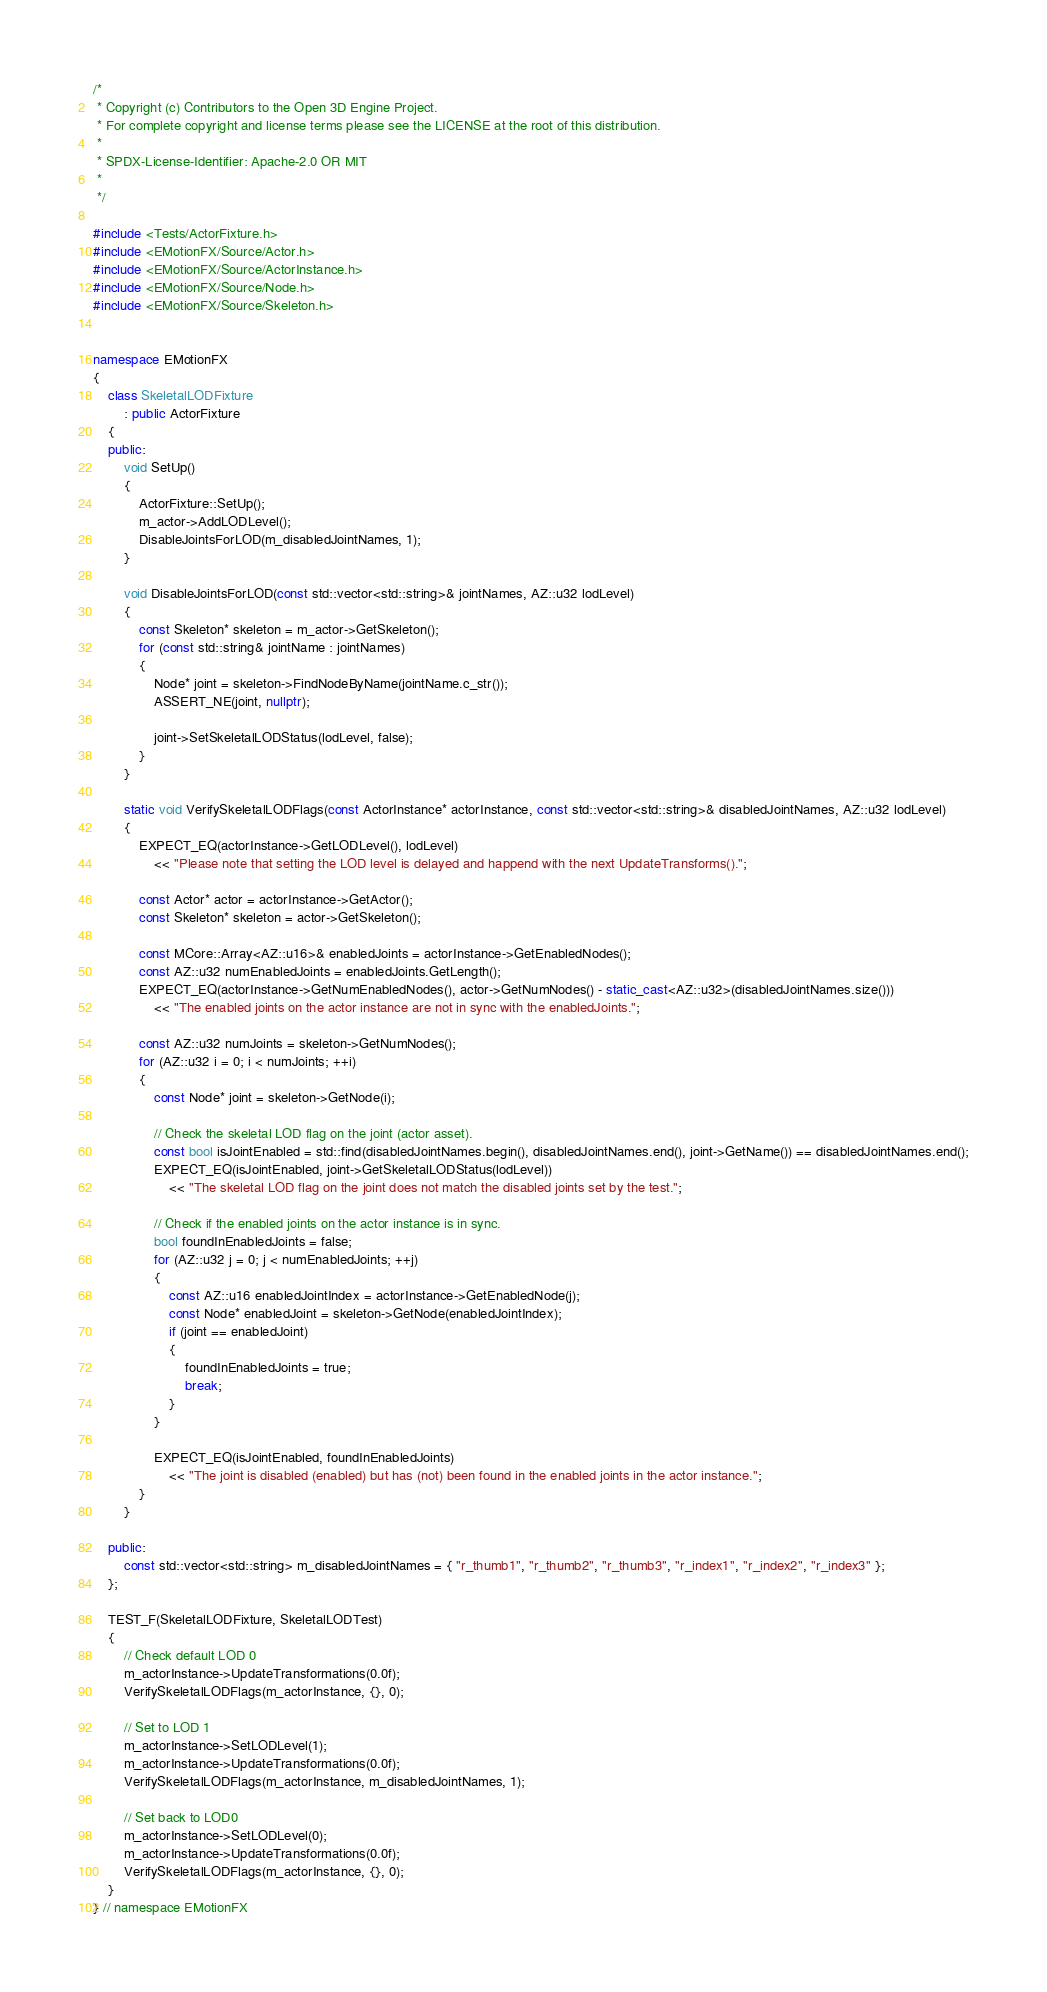Convert code to text. <code><loc_0><loc_0><loc_500><loc_500><_C++_>/*
 * Copyright (c) Contributors to the Open 3D Engine Project.
 * For complete copyright and license terms please see the LICENSE at the root of this distribution.
 *
 * SPDX-License-Identifier: Apache-2.0 OR MIT
 *
 */

#include <Tests/ActorFixture.h>
#include <EMotionFX/Source/Actor.h>
#include <EMotionFX/Source/ActorInstance.h>
#include <EMotionFX/Source/Node.h>
#include <EMotionFX/Source/Skeleton.h>


namespace EMotionFX
{
    class SkeletalLODFixture
        : public ActorFixture
    {
    public:
        void SetUp()
        {
            ActorFixture::SetUp();
            m_actor->AddLODLevel();
            DisableJointsForLOD(m_disabledJointNames, 1);
        }

        void DisableJointsForLOD(const std::vector<std::string>& jointNames, AZ::u32 lodLevel)
        {
            const Skeleton* skeleton = m_actor->GetSkeleton();
            for (const std::string& jointName : jointNames)
            {
                Node* joint = skeleton->FindNodeByName(jointName.c_str());
                ASSERT_NE(joint, nullptr);

                joint->SetSkeletalLODStatus(lodLevel, false);
            }
        }

        static void VerifySkeletalLODFlags(const ActorInstance* actorInstance, const std::vector<std::string>& disabledJointNames, AZ::u32 lodLevel)
        {
            EXPECT_EQ(actorInstance->GetLODLevel(), lodLevel)
                << "Please note that setting the LOD level is delayed and happend with the next UpdateTransforms().";

            const Actor* actor = actorInstance->GetActor();
            const Skeleton* skeleton = actor->GetSkeleton();

            const MCore::Array<AZ::u16>& enabledJoints = actorInstance->GetEnabledNodes();
            const AZ::u32 numEnabledJoints = enabledJoints.GetLength();
            EXPECT_EQ(actorInstance->GetNumEnabledNodes(), actor->GetNumNodes() - static_cast<AZ::u32>(disabledJointNames.size()))
                << "The enabled joints on the actor instance are not in sync with the enabledJoints.";

            const AZ::u32 numJoints = skeleton->GetNumNodes();
            for (AZ::u32 i = 0; i < numJoints; ++i)
            {
                const Node* joint = skeleton->GetNode(i);

                // Check the skeletal LOD flag on the joint (actor asset).
                const bool isJointEnabled = std::find(disabledJointNames.begin(), disabledJointNames.end(), joint->GetName()) == disabledJointNames.end();
                EXPECT_EQ(isJointEnabled, joint->GetSkeletalLODStatus(lodLevel))
                    << "The skeletal LOD flag on the joint does not match the disabled joints set by the test.";

                // Check if the enabled joints on the actor instance is in sync.
                bool foundInEnabledJoints = false;
                for (AZ::u32 j = 0; j < numEnabledJoints; ++j)
                {
                    const AZ::u16 enabledJointIndex = actorInstance->GetEnabledNode(j);
                    const Node* enabledJoint = skeleton->GetNode(enabledJointIndex);
                    if (joint == enabledJoint)
                    {
                        foundInEnabledJoints = true;
                        break;
                    }
                }

                EXPECT_EQ(isJointEnabled, foundInEnabledJoints)
                    << "The joint is disabled (enabled) but has (not) been found in the enabled joints in the actor instance.";
            }
        }

    public:
        const std::vector<std::string> m_disabledJointNames = { "r_thumb1", "r_thumb2", "r_thumb3", "r_index1", "r_index2", "r_index3" };
    };

    TEST_F(SkeletalLODFixture, SkeletalLODTest)
    {
        // Check default LOD 0
        m_actorInstance->UpdateTransformations(0.0f);
        VerifySkeletalLODFlags(m_actorInstance, {}, 0);

        // Set to LOD 1
        m_actorInstance->SetLODLevel(1);
        m_actorInstance->UpdateTransformations(0.0f);
        VerifySkeletalLODFlags(m_actorInstance, m_disabledJointNames, 1);

        // Set back to LOD0
        m_actorInstance->SetLODLevel(0);
        m_actorInstance->UpdateTransformations(0.0f);
        VerifySkeletalLODFlags(m_actorInstance, {}, 0);
    }
} // namespace EMotionFX
</code> 